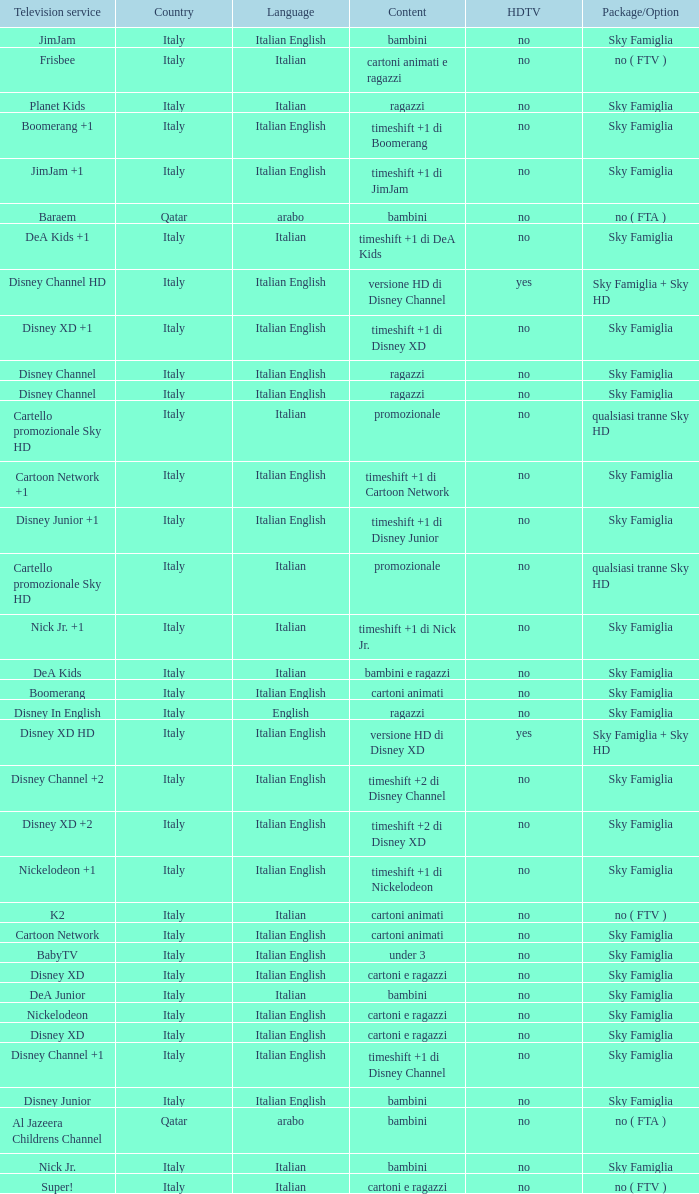Parse the table in full. {'header': ['Television service', 'Country', 'Language', 'Content', 'HDTV', 'Package/Option'], 'rows': [['JimJam', 'Italy', 'Italian English', 'bambini', 'no', 'Sky Famiglia'], ['Frisbee', 'Italy', 'Italian', 'cartoni animati e ragazzi', 'no', 'no ( FTV )'], ['Planet Kids', 'Italy', 'Italian', 'ragazzi', 'no', 'Sky Famiglia'], ['Boomerang +1', 'Italy', 'Italian English', 'timeshift +1 di Boomerang', 'no', 'Sky Famiglia'], ['JimJam +1', 'Italy', 'Italian English', 'timeshift +1 di JimJam', 'no', 'Sky Famiglia'], ['Baraem', 'Qatar', 'arabo', 'bambini', 'no', 'no ( FTA )'], ['DeA Kids +1', 'Italy', 'Italian', 'timeshift +1 di DeA Kids', 'no', 'Sky Famiglia'], ['Disney Channel HD', 'Italy', 'Italian English', 'versione HD di Disney Channel', 'yes', 'Sky Famiglia + Sky HD'], ['Disney XD +1', 'Italy', 'Italian English', 'timeshift +1 di Disney XD', 'no', 'Sky Famiglia'], ['Disney Channel', 'Italy', 'Italian English', 'ragazzi', 'no', 'Sky Famiglia'], ['Disney Channel', 'Italy', 'Italian English', 'ragazzi', 'no', 'Sky Famiglia'], ['Cartello promozionale Sky HD', 'Italy', 'Italian', 'promozionale', 'no', 'qualsiasi tranne Sky HD'], ['Cartoon Network +1', 'Italy', 'Italian English', 'timeshift +1 di Cartoon Network', 'no', 'Sky Famiglia'], ['Disney Junior +1', 'Italy', 'Italian English', 'timeshift +1 di Disney Junior', 'no', 'Sky Famiglia'], ['Cartello promozionale Sky HD', 'Italy', 'Italian', 'promozionale', 'no', 'qualsiasi tranne Sky HD'], ['Nick Jr. +1', 'Italy', 'Italian', 'timeshift +1 di Nick Jr.', 'no', 'Sky Famiglia'], ['DeA Kids', 'Italy', 'Italian', 'bambini e ragazzi', 'no', 'Sky Famiglia'], ['Boomerang', 'Italy', 'Italian English', 'cartoni animati', 'no', 'Sky Famiglia'], ['Disney In English', 'Italy', 'English', 'ragazzi', 'no', 'Sky Famiglia'], ['Disney XD HD', 'Italy', 'Italian English', 'versione HD di Disney XD', 'yes', 'Sky Famiglia + Sky HD'], ['Disney Channel +2', 'Italy', 'Italian English', 'timeshift +2 di Disney Channel', 'no', 'Sky Famiglia'], ['Disney XD +2', 'Italy', 'Italian English', 'timeshift +2 di Disney XD', 'no', 'Sky Famiglia'], ['Nickelodeon +1', 'Italy', 'Italian English', 'timeshift +1 di Nickelodeon', 'no', 'Sky Famiglia'], ['K2', 'Italy', 'Italian', 'cartoni animati', 'no', 'no ( FTV )'], ['Cartoon Network', 'Italy', 'Italian English', 'cartoni animati', 'no', 'Sky Famiglia'], ['BabyTV', 'Italy', 'Italian English', 'under 3', 'no', 'Sky Famiglia'], ['Disney XD', 'Italy', 'Italian English', 'cartoni e ragazzi', 'no', 'Sky Famiglia'], ['DeA Junior', 'Italy', 'Italian', 'bambini', 'no', 'Sky Famiglia'], ['Nickelodeon', 'Italy', 'Italian English', 'cartoni e ragazzi', 'no', 'Sky Famiglia'], ['Disney XD', 'Italy', 'Italian English', 'cartoni e ragazzi', 'no', 'Sky Famiglia'], ['Disney Channel +1', 'Italy', 'Italian English', 'timeshift +1 di Disney Channel', 'no', 'Sky Famiglia'], ['Disney Junior', 'Italy', 'Italian English', 'bambini', 'no', 'Sky Famiglia'], ['Al Jazeera Childrens Channel', 'Qatar', 'arabo', 'bambini', 'no', 'no ( FTA )'], ['Nick Jr.', 'Italy', 'Italian', 'bambini', 'no', 'Sky Famiglia'], ['Super!', 'Italy', 'Italian', 'cartoni e ragazzi', 'no', 'no ( FTV )']]} What is the Country when the language is italian english, and the television service is disney xd +1? Italy. 